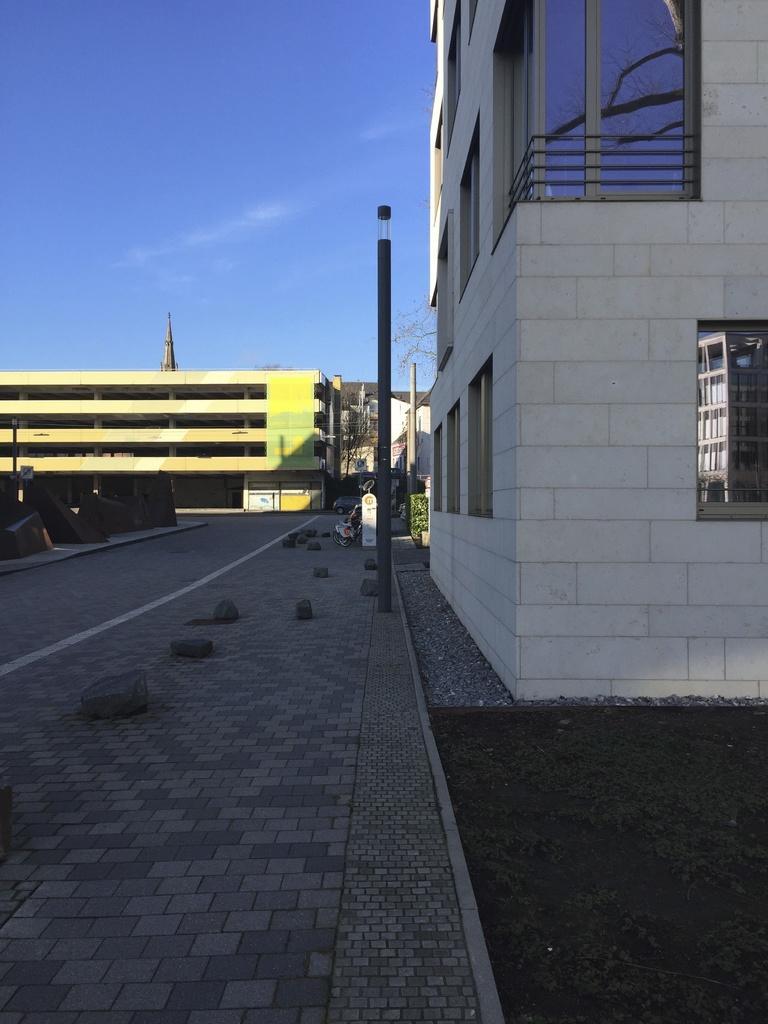Can you describe this image briefly? In this image I can see grass, buildings, poles, plants, fence, tower, trees, windows and the sky. This image is taken may be on the road. 